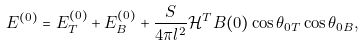Convert formula to latex. <formula><loc_0><loc_0><loc_500><loc_500>E ^ { ( 0 ) } = E ^ { ( 0 ) } _ { T } + E ^ { ( 0 ) } _ { B } + \frac { S } { 4 \pi l ^ { 2 } } \mathcal { H } ^ { T } B ( 0 ) \cos \theta _ { 0 T } \cos \theta _ { 0 B } ,</formula> 